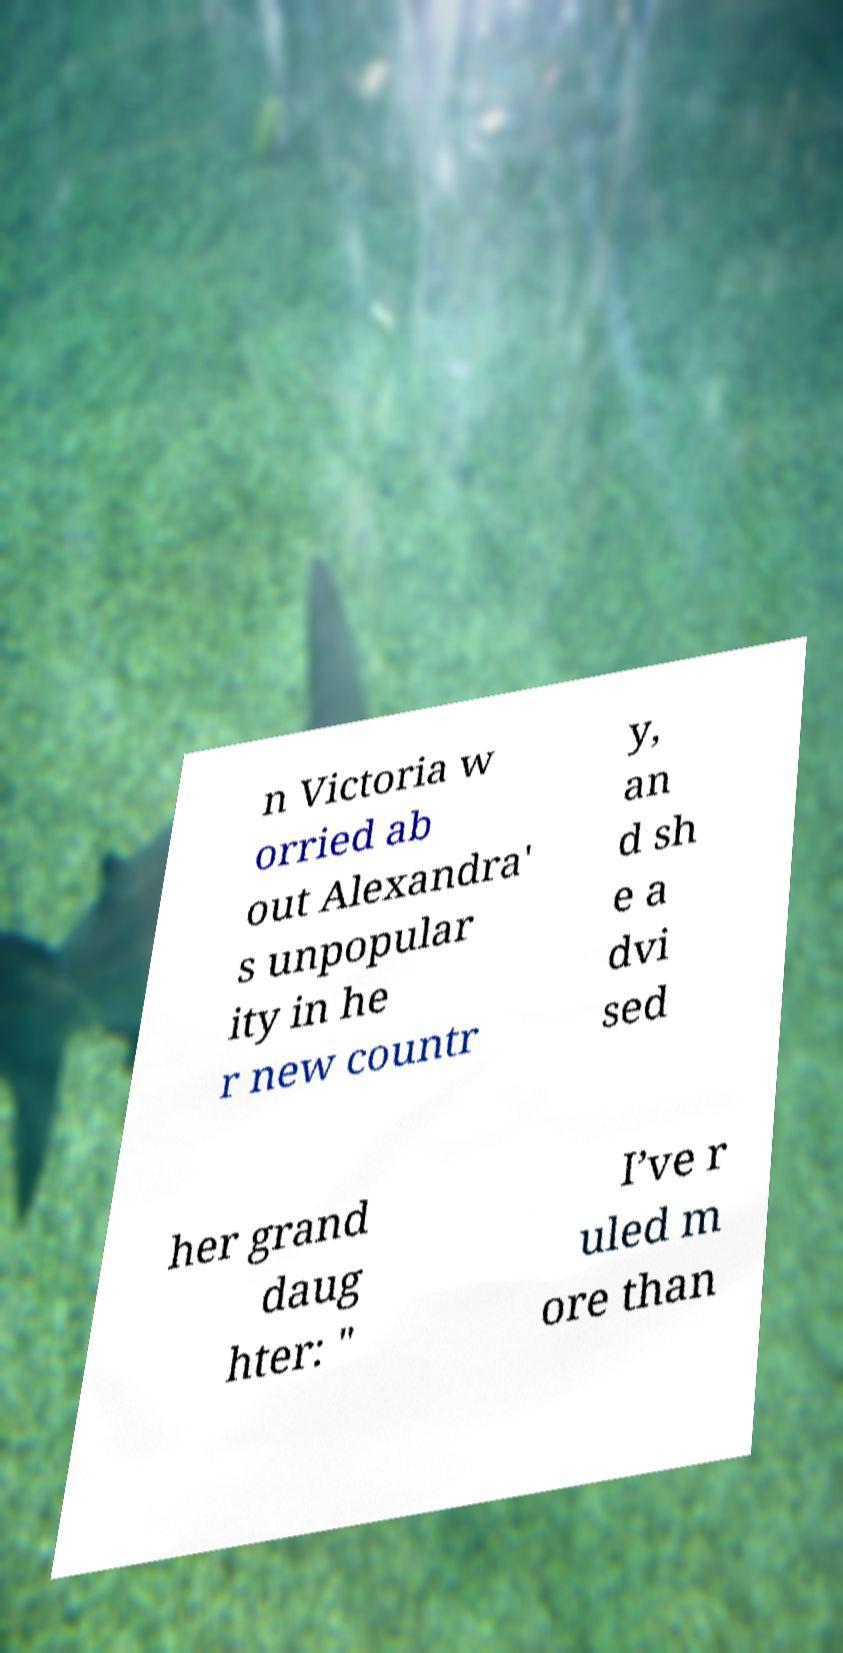Could you assist in decoding the text presented in this image and type it out clearly? n Victoria w orried ab out Alexandra' s unpopular ity in he r new countr y, an d sh e a dvi sed her grand daug hter: " I’ve r uled m ore than 